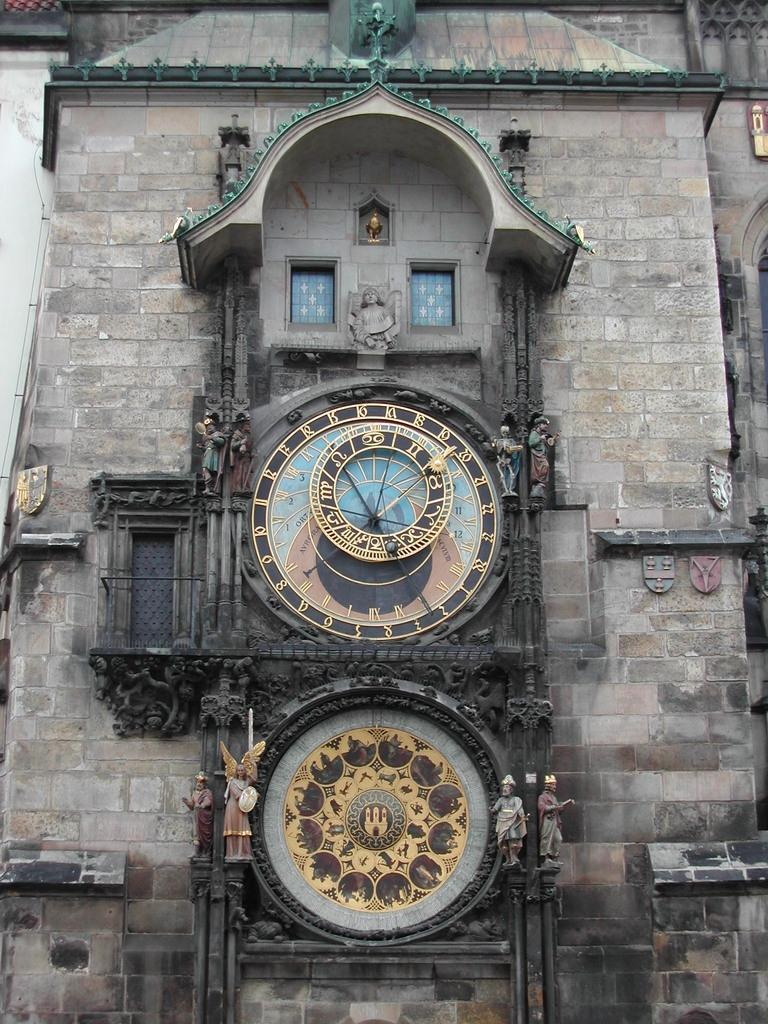<image>
Summarize the visual content of the image. A large brick building with a clock on the front that reads Avrora. 